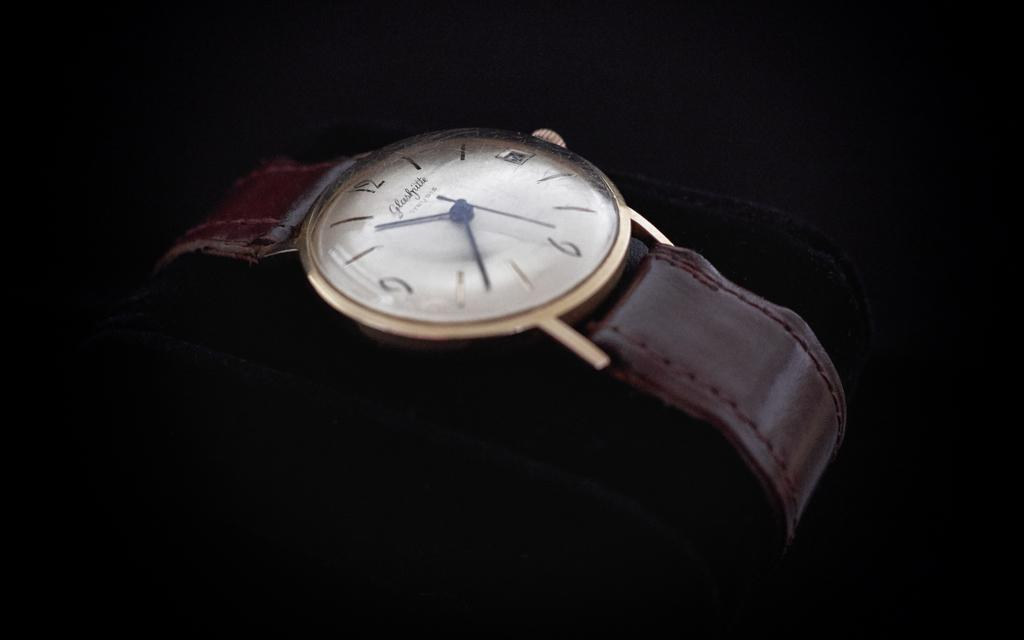<image>
Share a concise interpretation of the image provided. A Glashjiette brand of watch with a dark brown leather band. 